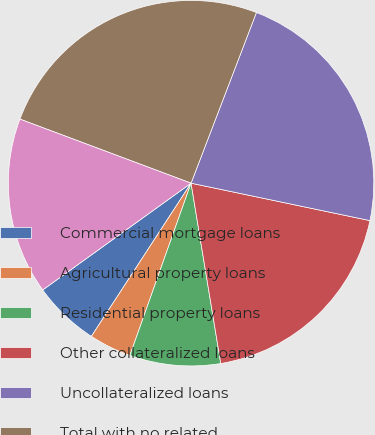Convert chart. <chart><loc_0><loc_0><loc_500><loc_500><pie_chart><fcel>Commercial mortgage loans<fcel>Agricultural property loans<fcel>Residential property loans<fcel>Other collateralized loans<fcel>Uncollateralized loans<fcel>Total with no related<fcel>Total with related allowance<nl><fcel>5.89%<fcel>3.75%<fcel>8.03%<fcel>19.12%<fcel>22.46%<fcel>25.12%<fcel>15.63%<nl></chart> 